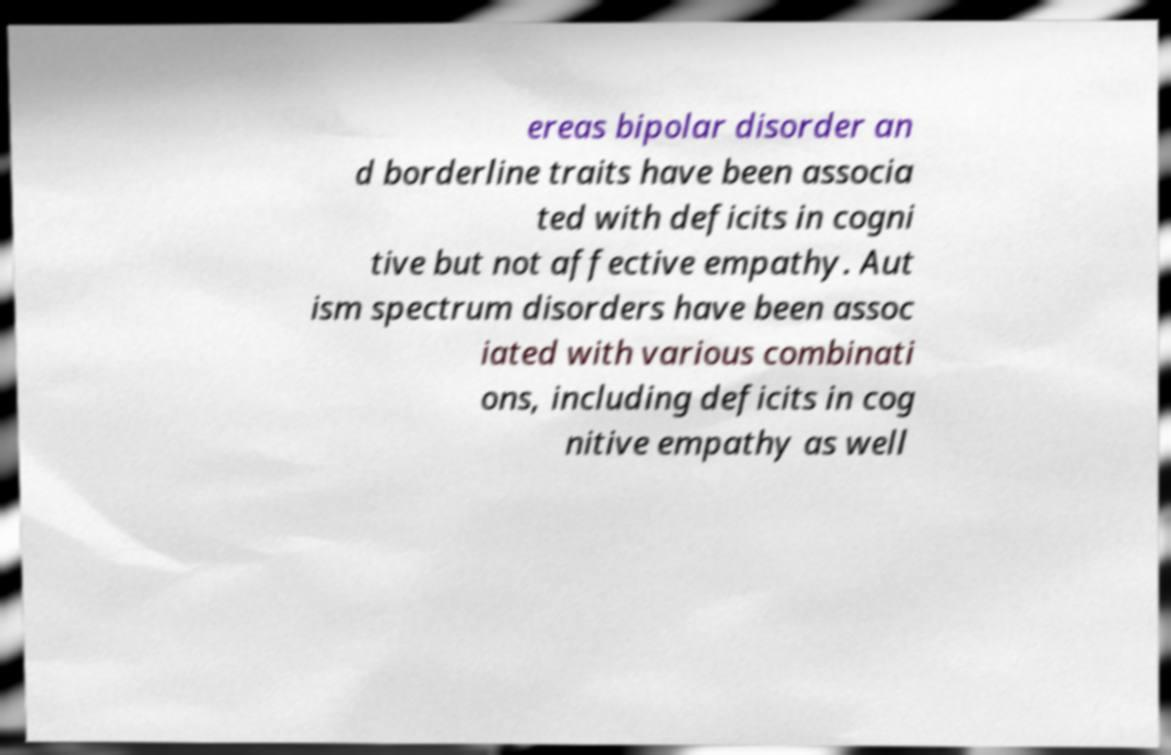I need the written content from this picture converted into text. Can you do that? ereas bipolar disorder an d borderline traits have been associa ted with deficits in cogni tive but not affective empathy. Aut ism spectrum disorders have been assoc iated with various combinati ons, including deficits in cog nitive empathy as well 